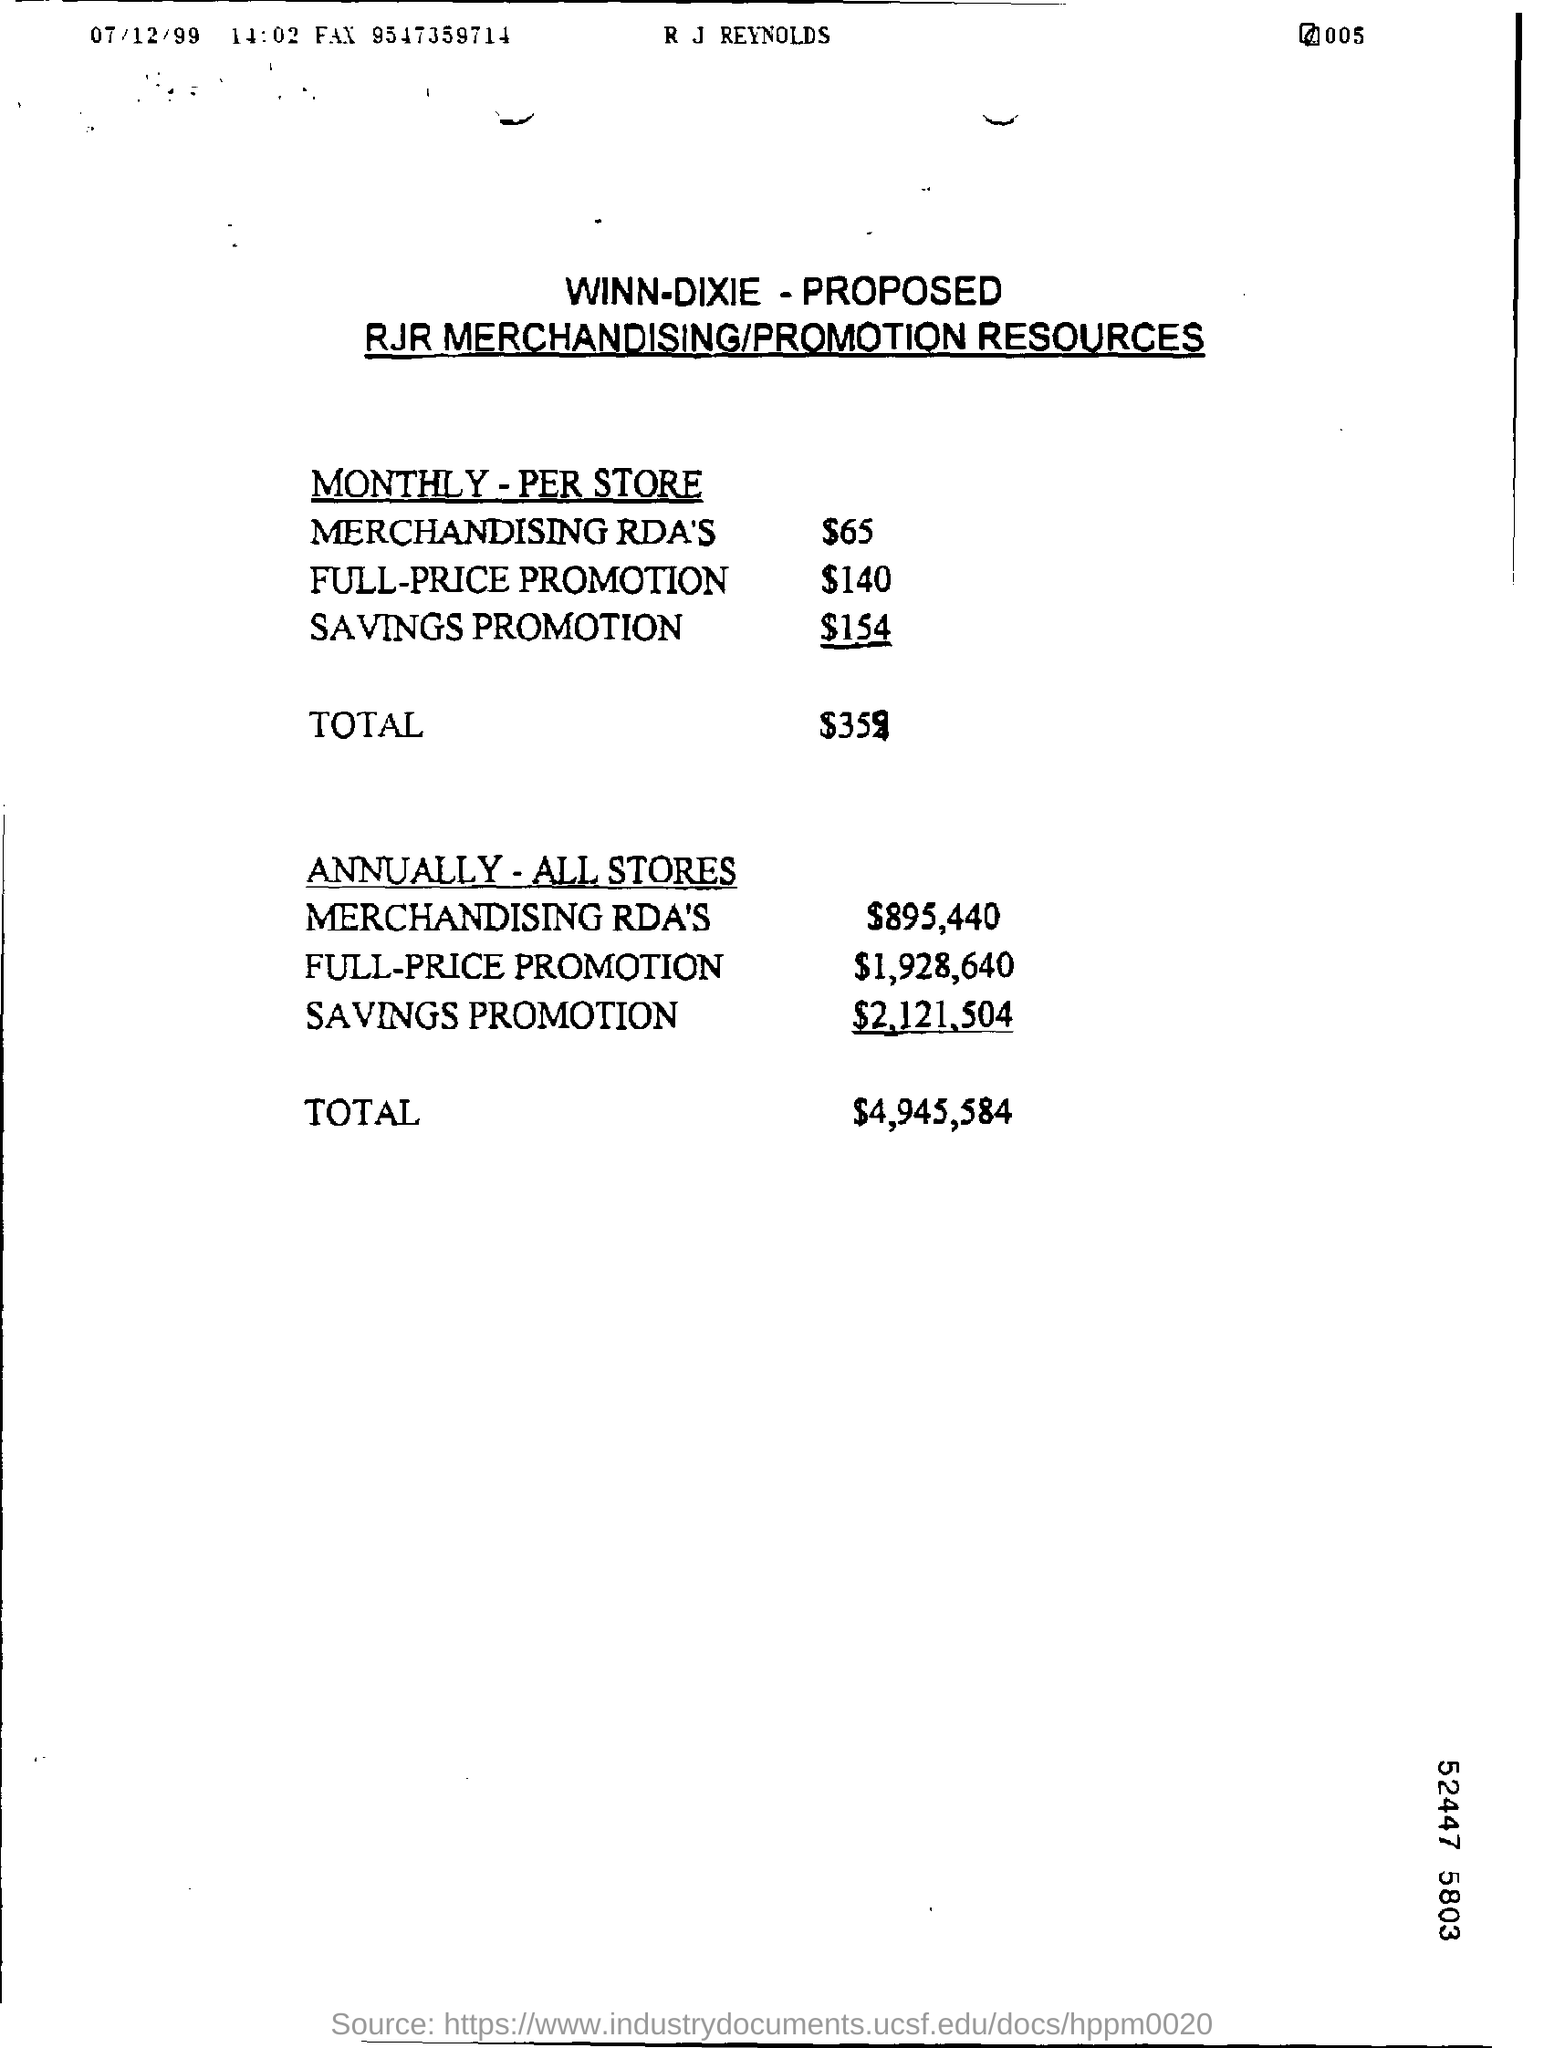List a handful of essential elements in this visual. The monthly merchandising RDA per store is $65. The total amount given for monthly per store is $359. The total amount for all stores annually is 4,945,584. The annual full price promotion amount for all stores is $1,928,640. The amount of merchandising RDA's for all stores annually is $895,440. 